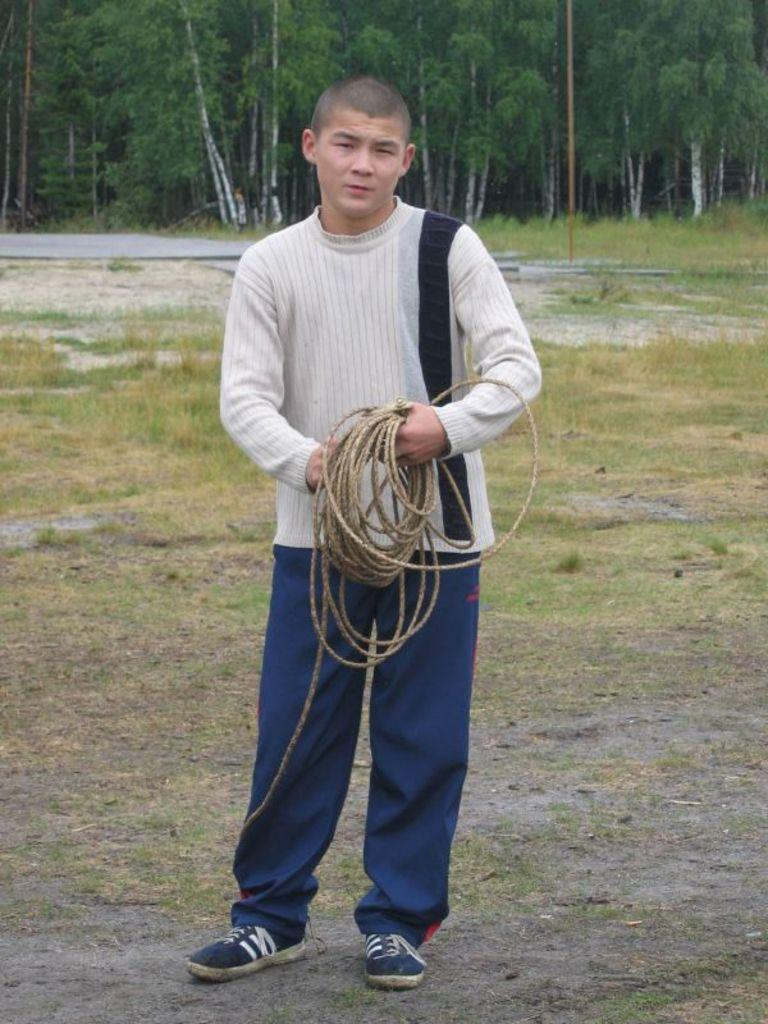Who or what is present in the image? There is a person in the image. What is the person holding in the image? The person is holding a rope. Where is the person standing in the image? The person is standing on the grass. What can be seen in the background of the image? There are trees in the background of the image. Is there a sink visible in the image? No, there is no sink present in the image. 